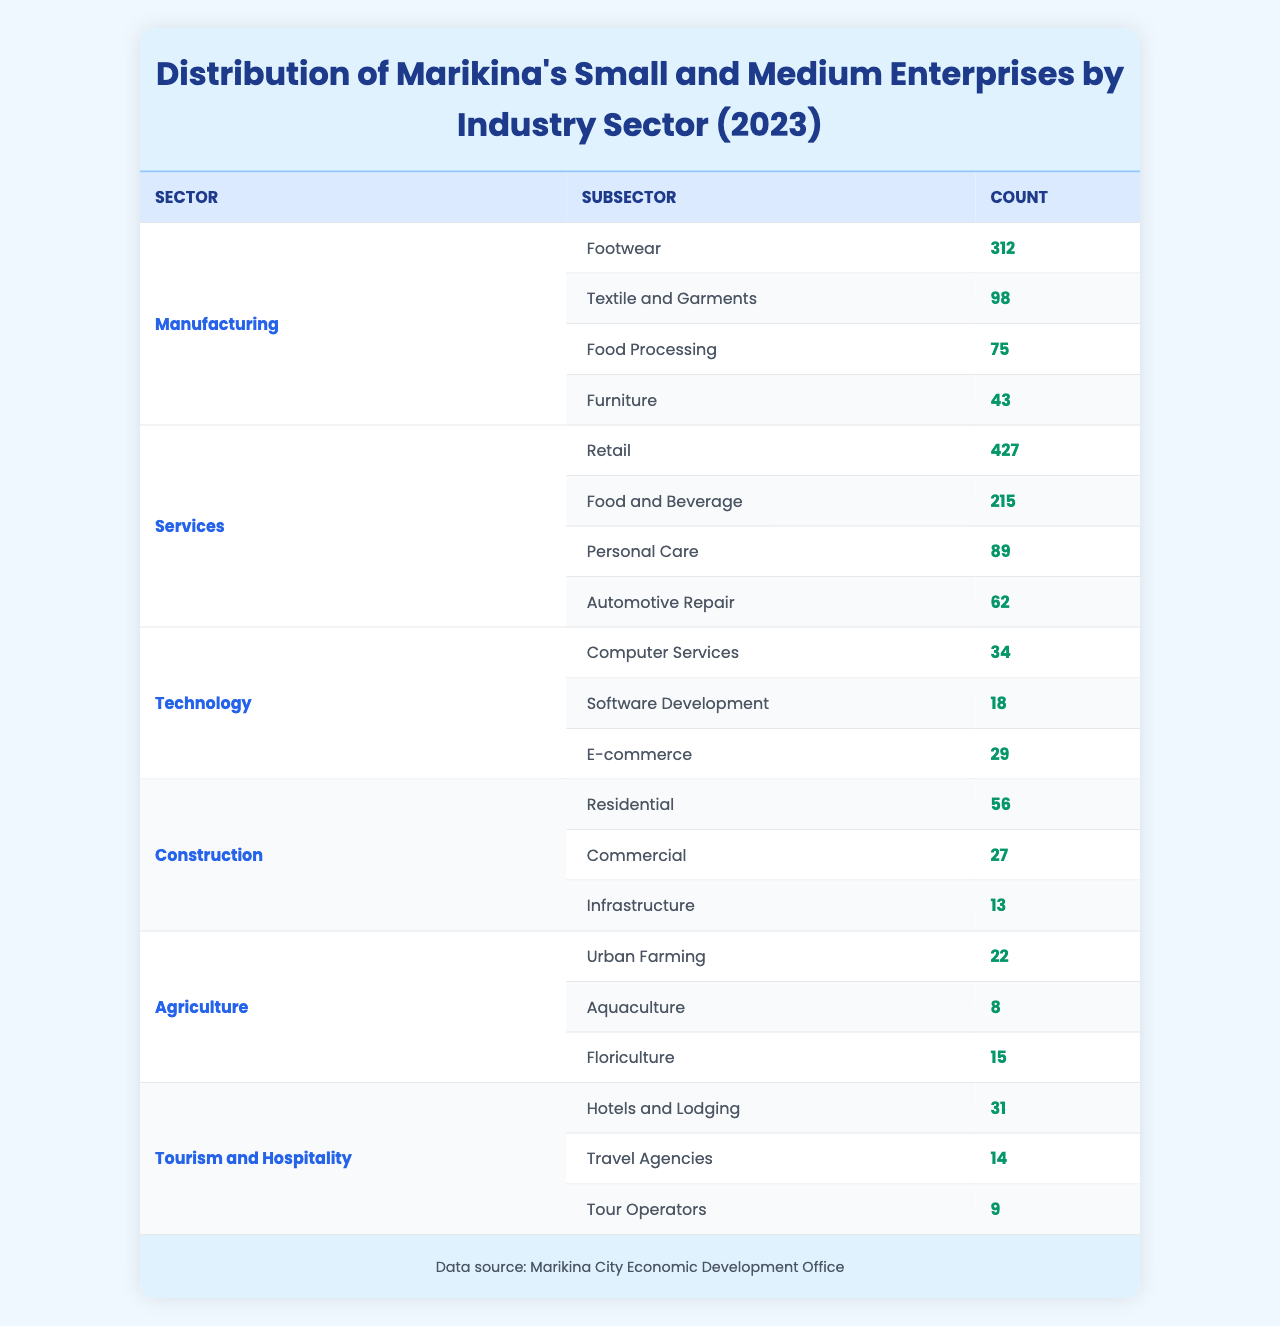What is the total number of small and medium enterprises in the manufacturing sector? The manufacturing sector has four subsectors: Footwear (312), Textile and Garments (98), Food Processing (75), and Furniture (43). Adding these values gives 312 + 98 + 75 + 43 = 528.
Answer: 528 Which service subsector has the highest number of enterprises? In the services sector, the subsectors are Retail (427), Food and Beverage (215), Personal Care (89), and Automotive Repair (62). The highest value among these is 427 for Retail, indicating it has the most enterprises.
Answer: Retail What is the total number of enterprises in the construction sector? The construction sector has three subsectors: Residential (56), Commercial (27), and Infrastructure (13). Summing these numbers gives 56 + 27 + 13 = 96.
Answer: 96 Are there more SMEs in the technology sector or the agriculture sector? The technology sector has a total of 34 + 18 + 29 = 81 enterprises, while the agriculture sector has 22 + 8 + 15 = 45 enterprises. Since 81 > 45, the technology sector has more SMEs.
Answer: Yes What is the average number of enterprises per subsector in the tourism and hospitality sector? The tourism and hospitality sector consists of three subsectors: Hotels and Lodging (31), Travel Agencies (14), and Tour Operators (9). Adding these gives 31 + 14 + 9 = 54. The average is 54/3 = 18.
Answer: 18 What percentage of enterprises in the services sector are in the Retail subsector? The total for the services sector is 427 + 215 + 89 + 62 = 793. The Retail subsector has 427 enterprises. To find the percentage, calculate (427 / 793) * 100 ≈ 53.9%.
Answer: Approximately 53.9% What is the combined total of SMEs in the agriculture and tourism sectors? The agriculture sector has a total of 22 + 8 + 15 = 45 enterprises, and the tourism sector has 31 + 14 + 9 = 54 enterprises. Adding these two total firms gives 45 + 54 = 99.
Answer: 99 Which subsector in the manufacturing industry has the least number of enterprises? In the manufacturing sector, the subsectors are Footwear (312), Textile and Garments (98), Food Processing (75), and Furniture (43). The least value is 43 for Furniture, indicating it has the fewest SMEs.
Answer: Furniture How many more enterprises are in the Food and Beverage sector compared to the Automotive Repair sector? The Food and Beverage sector has 215 SMEs, while the Automotive Repair sector has 62. The difference between these two is 215 - 62 = 153.
Answer: 153 What is the total count of SMEs across all sectors listed? The total for each sector is added up: Manufacturing (528) + Services (793) + Technology (81) + Construction (96) + Agriculture (45) + Tourism (54) = 1597.
Answer: 1597 